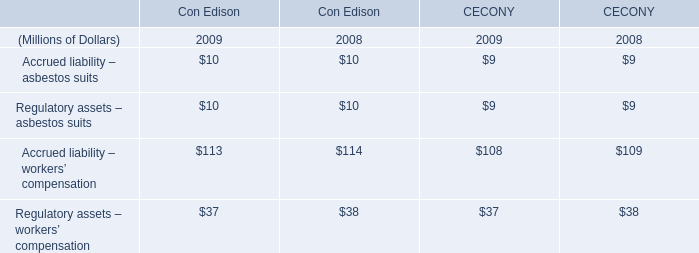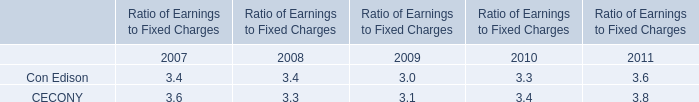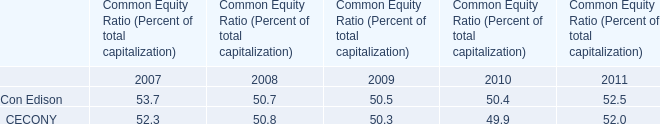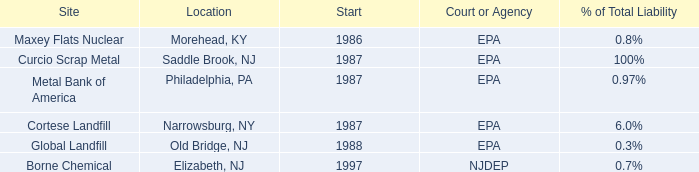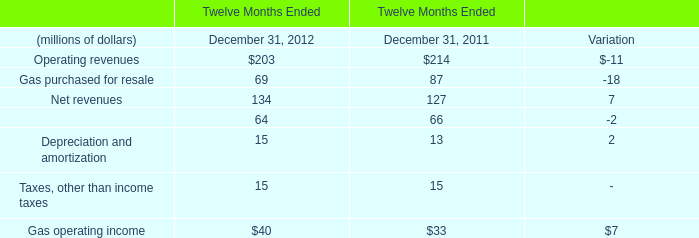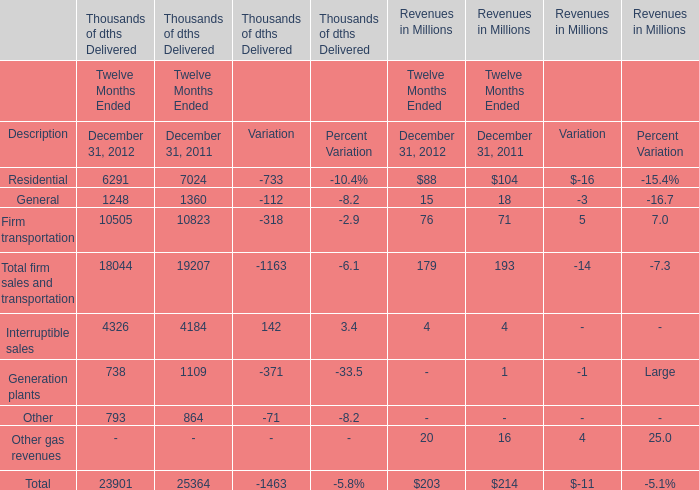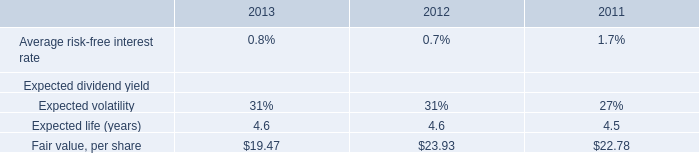If Firm transportation in Revenues in Millions develops with the same growth rate in 2012, what will it reach in 2013? (in millions) 
Computations: ((1 + ((76 - 71) / 71)) * 76)
Answer: 81.35211. 